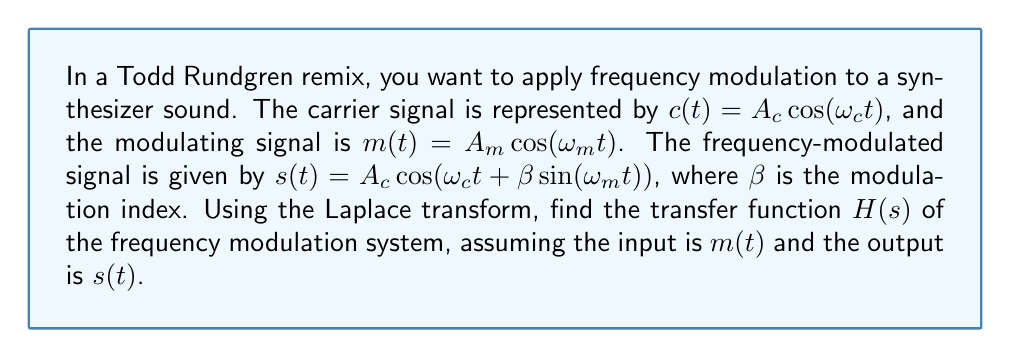Can you solve this math problem? Let's approach this step-by-step:

1) First, we need to linearize the frequency-modulated signal $s(t)$ for small values of $\beta$. Using the small-angle approximation, we get:

   $s(t) \approx A_c \cos(\omega_c t) - A_c \beta \sin(\omega_m t) \sin(\omega_c t)$

2) Using the trigonometric identity $\sin A \sin B = \frac{1}{2}[\cos(A-B) - \cos(A+B)]$, we can rewrite $s(t)$ as:

   $s(t) \approx A_c \cos(\omega_c t) - \frac{A_c \beta}{2} [\cos((\omega_c - \omega_m)t) - \cos((\omega_c + \omega_m)t)]$

3) Now, let's take the Laplace transform of both sides. Let $S(s)$ be the Laplace transform of $s(t)$ and $M(s)$ be the Laplace transform of $m(t)$:

   $S(s) = A_c \frac{s}{s^2 + \omega_c^2} - \frac{A_c \beta}{2} [\frac{s}{s^2 + (\omega_c - \omega_m)^2} - \frac{s}{s^2 + (\omega_c + \omega_m)^2}]$

4) The Laplace transform of $m(t) = A_m \cos(\omega_m t)$ is:

   $M(s) = A_m \frac{s}{s^2 + \omega_m^2}$

5) The transfer function $H(s)$ is defined as the ratio of the output transform to the input transform:

   $H(s) = \frac{S(s)}{M(s)}$

6) Substituting and simplifying:

   $H(s) = \frac{A_c}{A_m} \cdot \frac{s^2 + \omega_m^2}{s^2 + \omega_c^2} - \frac{A_c \beta}{2A_m} \cdot \frac{s^2 + \omega_m^2}{s^2 + \omega_c^2} \cdot [\frac{s}{s^2 + (\omega_c - \omega_m)^2} - \frac{s}{s^2 + (\omega_c + \omega_m)^2}]$

This is the transfer function of the frequency modulation system.
Answer: $H(s) = \frac{A_c}{A_m} \cdot \frac{s^2 + \omega_m^2}{s^2 + \omega_c^2} - \frac{A_c \beta}{2A_m} \cdot \frac{s^2 + \omega_m^2}{s^2 + \omega_c^2} \cdot [\frac{s}{s^2 + (\omega_c - \omega_m)^2} - \frac{s}{s^2 + (\omega_c + \omega_m)^2}]$ 